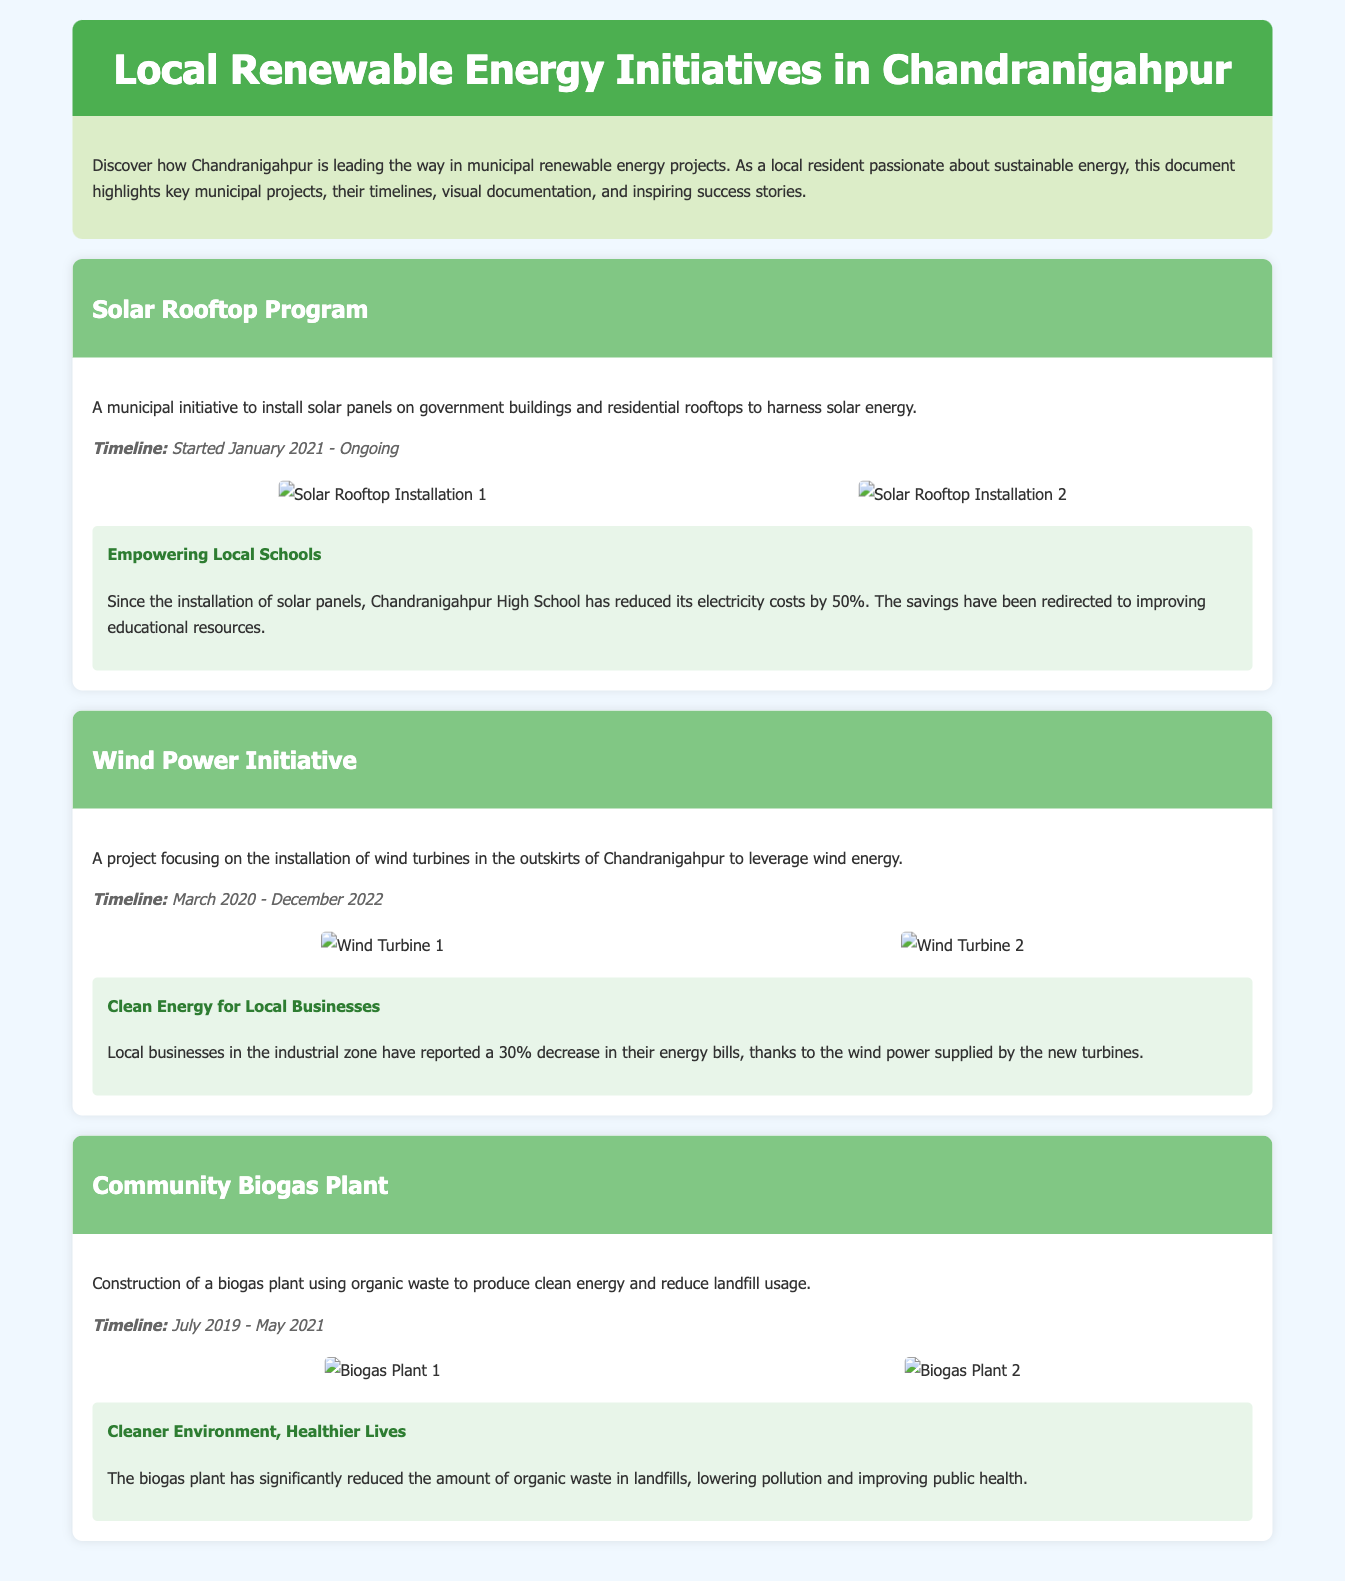What is the title of the document? The title of the document is stated at the top of the header section.
Answer: Local Renewable Energy Initiatives in Chandranigahpur When did the Solar Rooftop Program start? The timeline for the Solar Rooftop Program is provided in the project segment.
Answer: January 2021 What financial benefit did Chandranigahpur High School experience? The success story highlights the specific financial reduction experienced by the school.
Answer: 50% What is the end date of the Wind Power Initiative? The timeline for the Wind Power Initiative is mentioned in its project description.
Answer: December 2022 How much did local businesses save on their energy bills due to wind power? The success story quantifies the decrease in energy bills for local businesses.
Answer: 30% What type of energy is produced by the Community Biogas Plant? The project content specifies the type of energy produced by this initiative.
Answer: Clean energy What was a key outcome of the biogas plant regarding public health? The success story describes the positive impact on public health in relation to waste reduction.
Answer: Improving public health Name a project that is ongoing. The timeline of the projects indicates which ones are still in progress.
Answer: Solar Rooftop Program How many photos are displayed for the Wind Power Initiative? The project section includes visual documentation and states the number of photos.
Answer: 2 